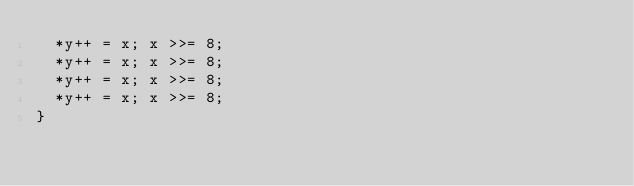<code> <loc_0><loc_0><loc_500><loc_500><_C_>  *y++ = x; x >>= 8;
  *y++ = x; x >>= 8;
  *y++ = x; x >>= 8;
  *y++ = x; x >>= 8;
}
</code> 